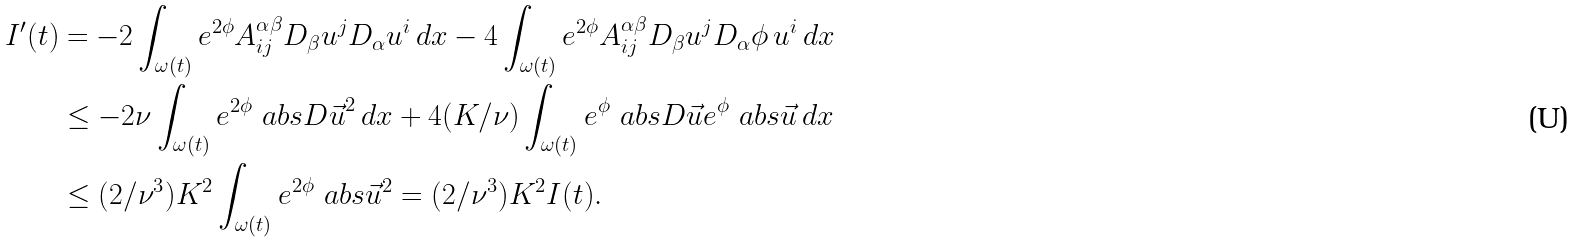Convert formula to latex. <formula><loc_0><loc_0><loc_500><loc_500>I ^ { \prime } ( t ) & = - 2 \int _ { \omega ( t ) } e ^ { 2 \phi } A ^ { \alpha \beta } _ { i j } D _ { \beta } u ^ { j } D _ { \alpha } u ^ { i } \, d x - 4 \int _ { \omega ( t ) } e ^ { 2 \phi } A ^ { \alpha \beta } _ { i j } D _ { \beta } u ^ { j } D _ { \alpha } \phi \, u ^ { i } \, d x \\ & \leq - 2 \nu \int _ { \omega ( t ) } e ^ { 2 \phi } \ a b s { D \vec { u } } ^ { 2 } \, d x + 4 ( K / \nu ) \int _ { \omega ( t ) } e ^ { \phi } \ a b s { D \vec { u } } e ^ { \phi } \ a b s { \vec { u } } \, d x \\ & \leq ( 2 / \nu ^ { 3 } ) K ^ { 2 } \int _ { \omega ( t ) } e ^ { 2 \phi } \ a b s { \vec { u } } ^ { 2 } = ( 2 / \nu ^ { 3 } ) K ^ { 2 } I ( t ) .</formula> 